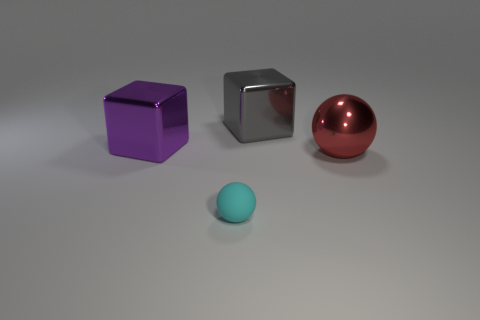Is there a shiny thing that is right of the big block that is on the left side of the small rubber thing?
Offer a very short reply. Yes. Is the number of big red spheres less than the number of small blue metallic spheres?
Provide a succinct answer. No. The cube to the left of the ball that is in front of the large red shiny thing is made of what material?
Provide a short and direct response. Metal. Does the red metal object have the same size as the gray cube?
Make the answer very short. Yes. What number of things are either cyan matte balls or gray shiny blocks?
Provide a succinct answer. 2. There is a thing that is both to the right of the small cyan rubber sphere and to the left of the big red metallic ball; what is its size?
Ensure brevity in your answer.  Large. Is the number of balls that are on the right side of the purple metal block less than the number of big blocks?
Give a very brief answer. No. What is the shape of the big red object that is the same material as the gray object?
Provide a short and direct response. Sphere. Do the big metal thing behind the big purple thing and the large metallic thing that is in front of the large purple metallic block have the same shape?
Offer a terse response. No. Are there fewer small rubber objects behind the matte sphere than things to the left of the gray metal cube?
Provide a short and direct response. Yes. 